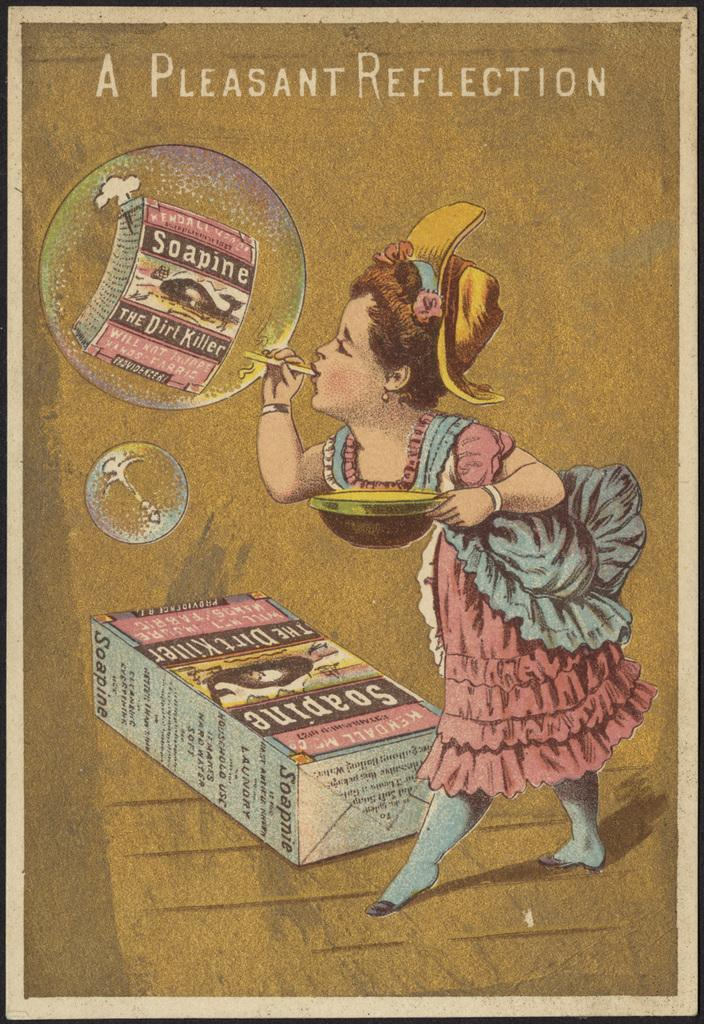Who is the main subject in the image? There is a girl in the image. What is the girl holding in the image? The girl is holding an object. Can you describe the object the girl is holding? The object has text written on it. How many snails can be seen crawling on the girl's arm in the image? There are no snails present in the image. What type of fiction is the girl reading from the object she is holding? The image does not show the girl reading any fiction, nor does it show the content of the text on the object. 